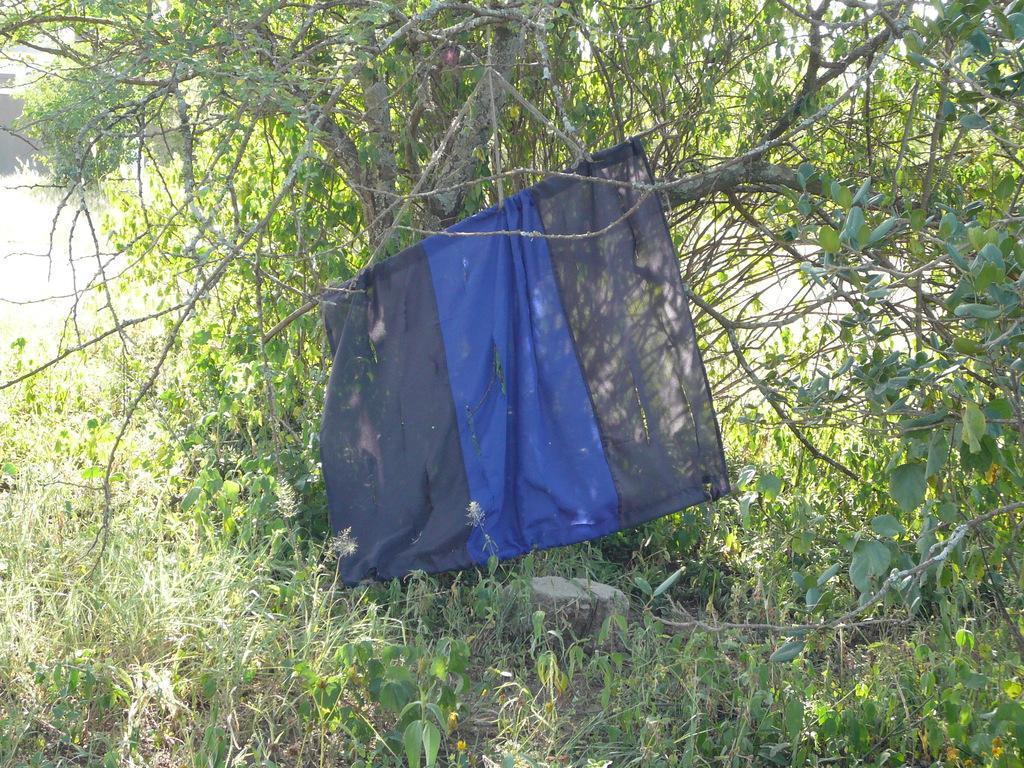Could you give a brief overview of what you see in this image? In this picture I can see full of grass, trees in between the tree we can see the cloth. 